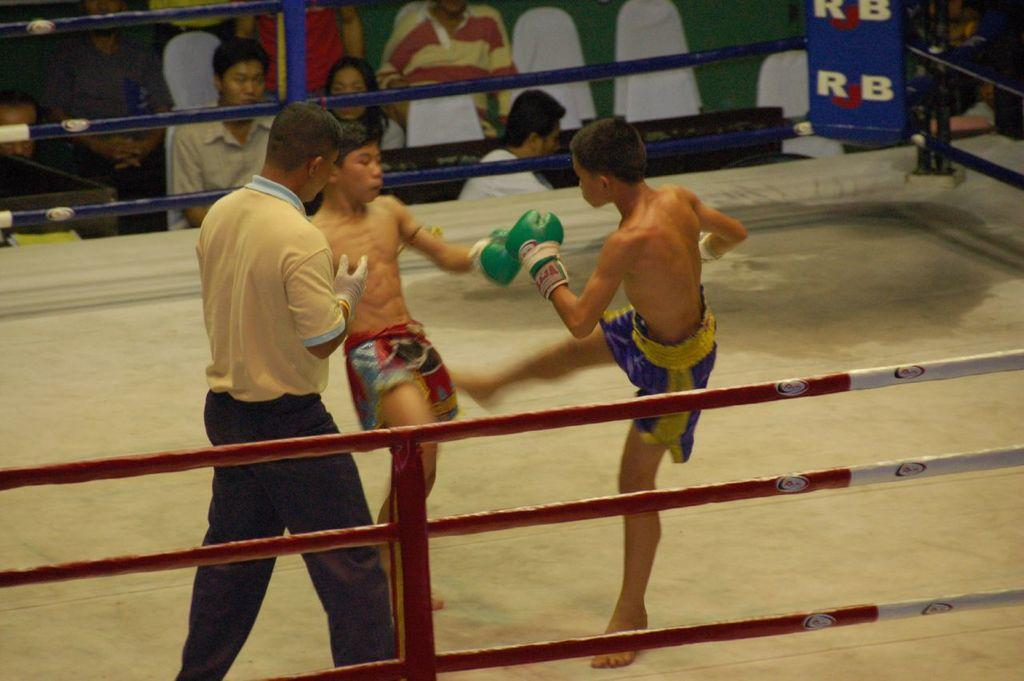<image>
Relay a brief, clear account of the picture shown. Two young men fight in a ring with a corner padding that says RJB. 